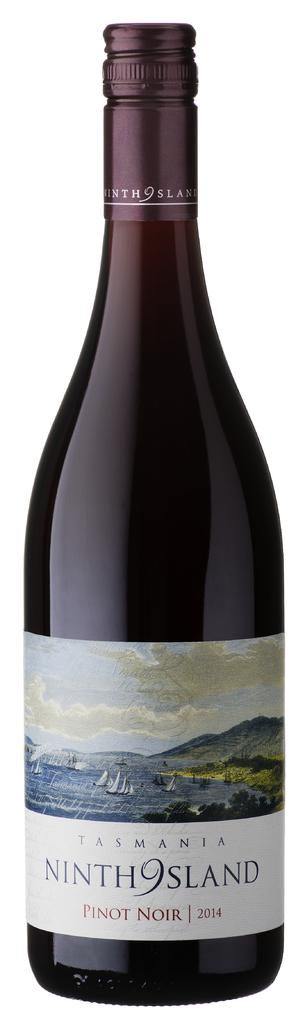<image>
Summarize the visual content of the image. A bottle of wine says that it is Pinot Noir 2014. 